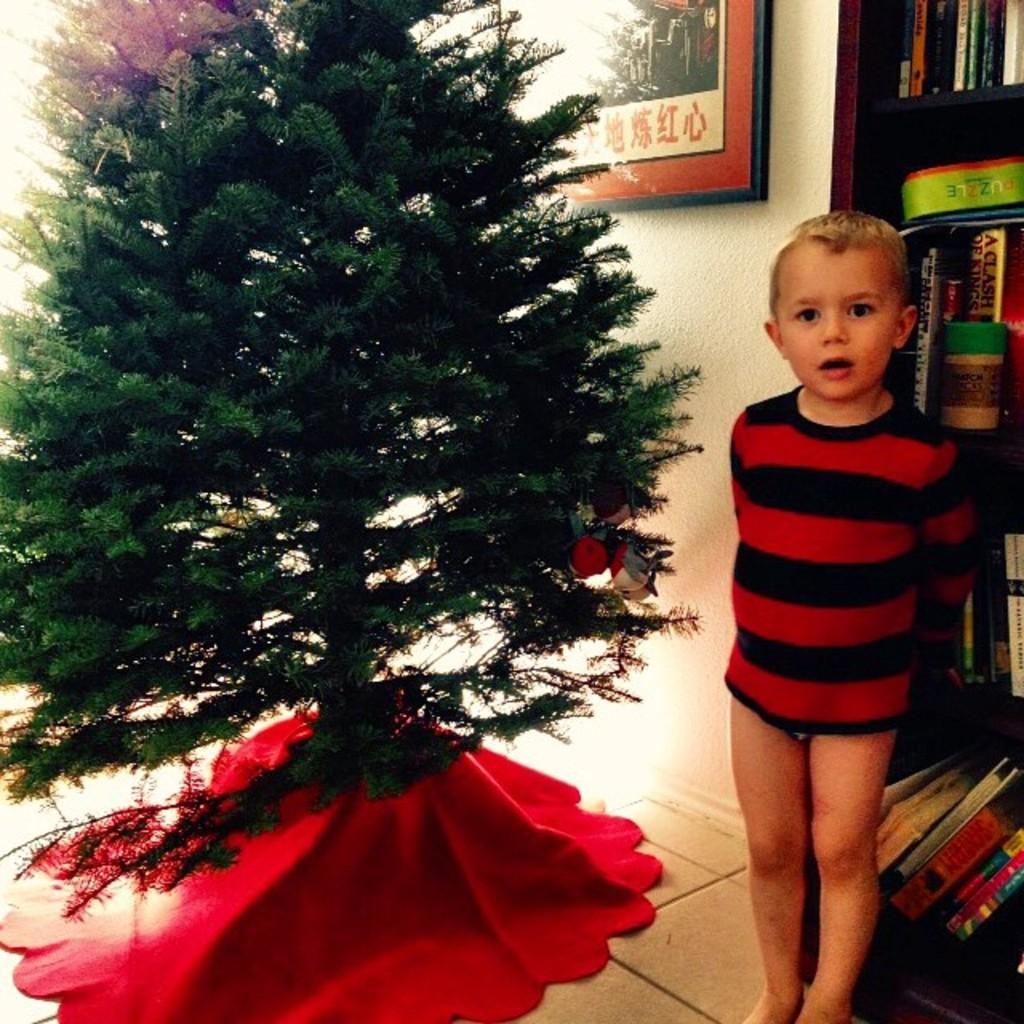Describe this image in one or two sentences. In this picture we can see a boy,beside to him we can see a Christmas tree and in the background we can see a wall,photo frame,books. 